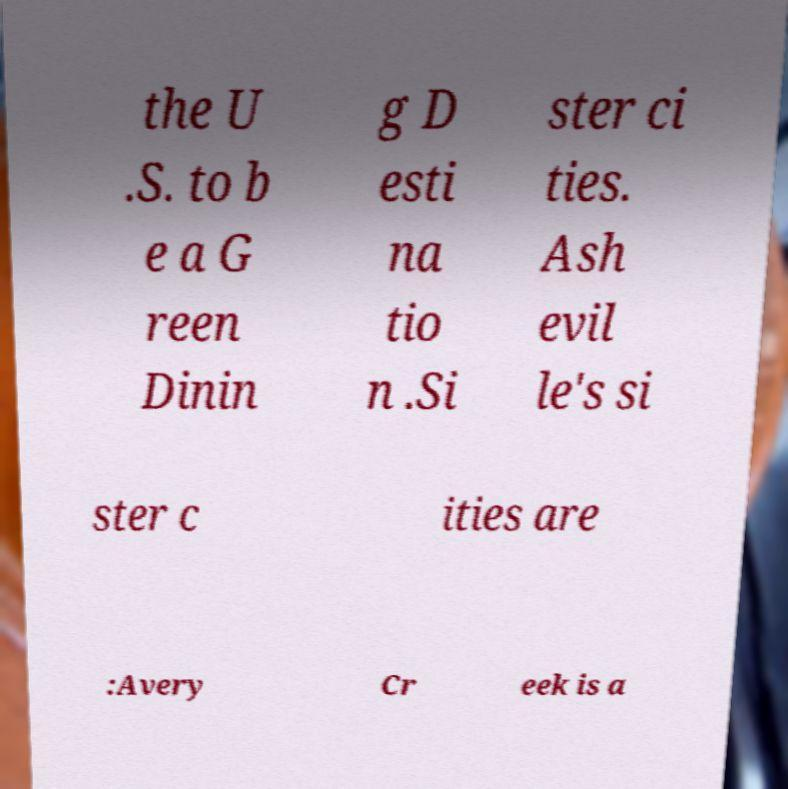Could you assist in decoding the text presented in this image and type it out clearly? the U .S. to b e a G reen Dinin g D esti na tio n .Si ster ci ties. Ash evil le's si ster c ities are :Avery Cr eek is a 